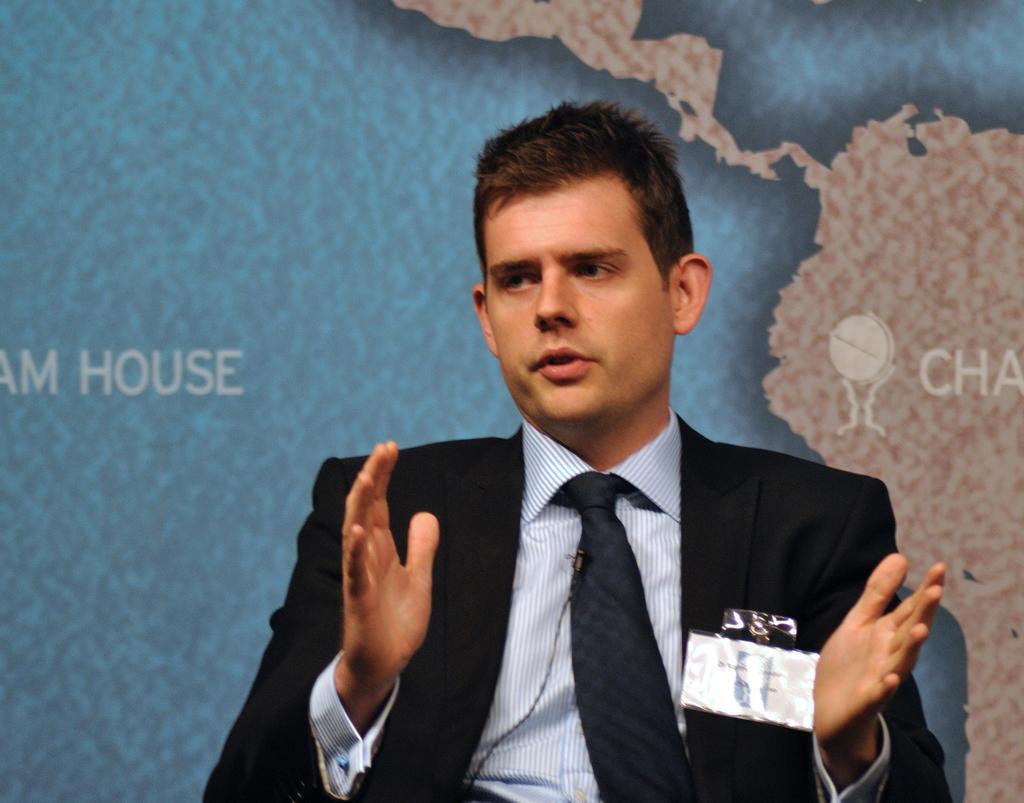Describe this image in one or two sentences. In this image we can see a person is sitting on the chair and explaining something and back of him a map like image is there. 